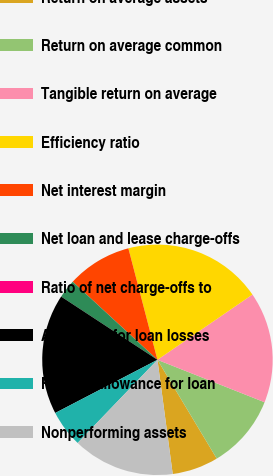Convert chart. <chart><loc_0><loc_0><loc_500><loc_500><pie_chart><fcel>Return on average assets<fcel>Return on average common<fcel>Tangible return on average<fcel>Efficiency ratio<fcel>Net interest margin<fcel>Net loan and lease charge-offs<fcel>Ratio of net charge-offs to<fcel>Allowance for loan losses<fcel>Ratio of allowance for loan<fcel>Nonperforming assets<nl><fcel>6.49%<fcel>10.39%<fcel>15.58%<fcel>19.48%<fcel>9.09%<fcel>2.6%<fcel>0.0%<fcel>16.88%<fcel>5.19%<fcel>14.29%<nl></chart> 